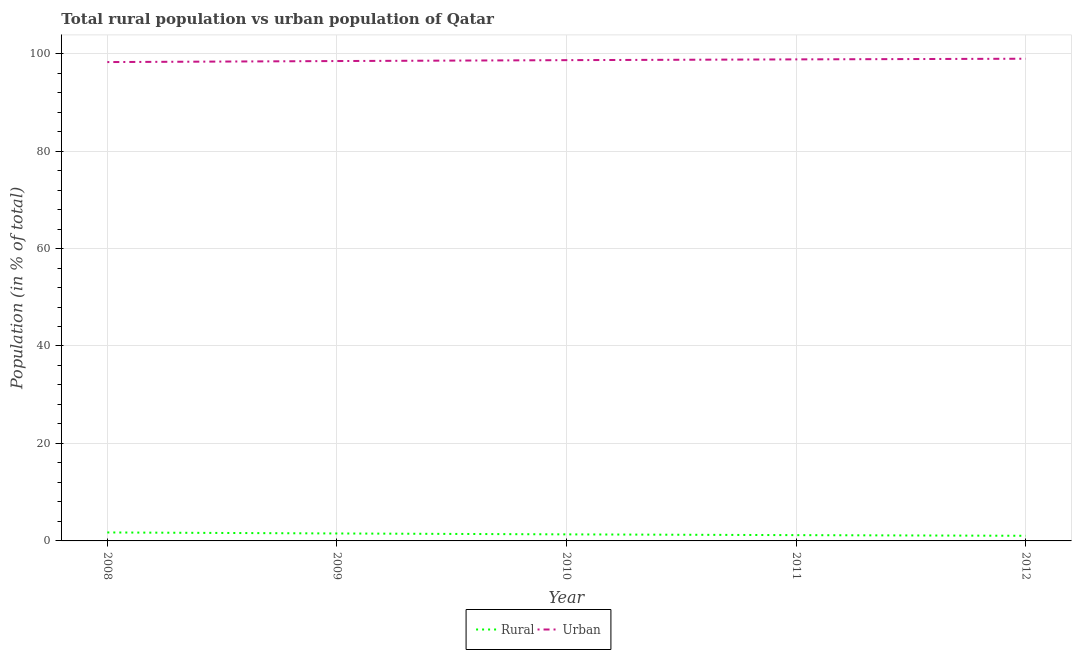Does the line corresponding to rural population intersect with the line corresponding to urban population?
Offer a terse response. No. What is the urban population in 2008?
Provide a short and direct response. 98.26. Across all years, what is the maximum urban population?
Offer a terse response. 98.95. Across all years, what is the minimum urban population?
Offer a very short reply. 98.26. In which year was the urban population maximum?
Your answer should be compact. 2012. What is the total urban population in the graph?
Provide a succinct answer. 493.14. What is the difference between the rural population in 2011 and that in 2012?
Your answer should be very brief. 0.13. What is the difference between the urban population in 2010 and the rural population in 2011?
Offer a very short reply. 97.47. What is the average rural population per year?
Your response must be concise. 1.37. In the year 2009, what is the difference between the urban population and rural population?
Keep it short and to the point. 96.94. In how many years, is the rural population greater than 12 %?
Ensure brevity in your answer.  0. What is the ratio of the rural population in 2008 to that in 2010?
Your answer should be compact. 1.29. What is the difference between the highest and the second highest rural population?
Offer a very short reply. 0.21. What is the difference between the highest and the lowest urban population?
Your answer should be compact. 0.69. In how many years, is the urban population greater than the average urban population taken over all years?
Your answer should be very brief. 3. Does the urban population monotonically increase over the years?
Give a very brief answer. Yes. How many lines are there?
Your answer should be very brief. 2. How many years are there in the graph?
Keep it short and to the point. 5. What is the difference between two consecutive major ticks on the Y-axis?
Your answer should be very brief. 20. Are the values on the major ticks of Y-axis written in scientific E-notation?
Give a very brief answer. No. Does the graph contain any zero values?
Offer a terse response. No. How many legend labels are there?
Make the answer very short. 2. What is the title of the graph?
Give a very brief answer. Total rural population vs urban population of Qatar. Does "Electricity and heat production" appear as one of the legend labels in the graph?
Your answer should be compact. No. What is the label or title of the Y-axis?
Your response must be concise. Population (in % of total). What is the Population (in % of total) of Rural in 2008?
Keep it short and to the point. 1.74. What is the Population (in % of total) of Urban in 2008?
Offer a very short reply. 98.26. What is the Population (in % of total) in Rural in 2009?
Your response must be concise. 1.53. What is the Population (in % of total) of Urban in 2009?
Provide a short and direct response. 98.47. What is the Population (in % of total) in Rural in 2010?
Offer a very short reply. 1.34. What is the Population (in % of total) in Urban in 2010?
Provide a succinct answer. 98.66. What is the Population (in % of total) of Rural in 2011?
Provide a succinct answer. 1.19. What is the Population (in % of total) of Urban in 2011?
Provide a succinct answer. 98.81. What is the Population (in % of total) of Rural in 2012?
Give a very brief answer. 1.05. What is the Population (in % of total) of Urban in 2012?
Your answer should be compact. 98.95. Across all years, what is the maximum Population (in % of total) in Rural?
Your answer should be very brief. 1.74. Across all years, what is the maximum Population (in % of total) of Urban?
Offer a very short reply. 98.95. Across all years, what is the minimum Population (in % of total) in Rural?
Keep it short and to the point. 1.05. Across all years, what is the minimum Population (in % of total) of Urban?
Offer a very short reply. 98.26. What is the total Population (in % of total) of Rural in the graph?
Keep it short and to the point. 6.86. What is the total Population (in % of total) in Urban in the graph?
Provide a succinct answer. 493.14. What is the difference between the Population (in % of total) in Rural in 2008 and that in 2009?
Provide a short and direct response. 0.21. What is the difference between the Population (in % of total) of Urban in 2008 and that in 2009?
Offer a terse response. -0.21. What is the difference between the Population (in % of total) in Rural in 2008 and that in 2010?
Give a very brief answer. 0.39. What is the difference between the Population (in % of total) of Urban in 2008 and that in 2010?
Provide a succinct answer. -0.39. What is the difference between the Population (in % of total) in Rural in 2008 and that in 2011?
Offer a terse response. 0.55. What is the difference between the Population (in % of total) in Urban in 2008 and that in 2011?
Give a very brief answer. -0.55. What is the difference between the Population (in % of total) in Rural in 2008 and that in 2012?
Provide a succinct answer. 0.69. What is the difference between the Population (in % of total) of Urban in 2008 and that in 2012?
Make the answer very short. -0.69. What is the difference between the Population (in % of total) in Rural in 2009 and that in 2010?
Offer a very short reply. 0.18. What is the difference between the Population (in % of total) of Urban in 2009 and that in 2010?
Make the answer very short. -0.18. What is the difference between the Population (in % of total) of Rural in 2009 and that in 2011?
Make the answer very short. 0.34. What is the difference between the Population (in % of total) in Urban in 2009 and that in 2011?
Give a very brief answer. -0.34. What is the difference between the Population (in % of total) of Rural in 2009 and that in 2012?
Your answer should be very brief. 0.48. What is the difference between the Population (in % of total) in Urban in 2009 and that in 2012?
Keep it short and to the point. -0.48. What is the difference between the Population (in % of total) in Rural in 2010 and that in 2011?
Provide a short and direct response. 0.16. What is the difference between the Population (in % of total) of Urban in 2010 and that in 2011?
Your response must be concise. -0.16. What is the difference between the Population (in % of total) in Rural in 2010 and that in 2012?
Provide a succinct answer. 0.29. What is the difference between the Population (in % of total) in Urban in 2010 and that in 2012?
Offer a very short reply. -0.29. What is the difference between the Population (in % of total) in Rural in 2011 and that in 2012?
Your answer should be very brief. 0.13. What is the difference between the Population (in % of total) in Urban in 2011 and that in 2012?
Ensure brevity in your answer.  -0.13. What is the difference between the Population (in % of total) in Rural in 2008 and the Population (in % of total) in Urban in 2009?
Keep it short and to the point. -96.73. What is the difference between the Population (in % of total) of Rural in 2008 and the Population (in % of total) of Urban in 2010?
Ensure brevity in your answer.  -96.92. What is the difference between the Population (in % of total) in Rural in 2008 and the Population (in % of total) in Urban in 2011?
Provide a short and direct response. -97.07. What is the difference between the Population (in % of total) in Rural in 2008 and the Population (in % of total) in Urban in 2012?
Make the answer very short. -97.21. What is the difference between the Population (in % of total) in Rural in 2009 and the Population (in % of total) in Urban in 2010?
Your answer should be very brief. -97.12. What is the difference between the Population (in % of total) in Rural in 2009 and the Population (in % of total) in Urban in 2011?
Provide a short and direct response. -97.28. What is the difference between the Population (in % of total) in Rural in 2009 and the Population (in % of total) in Urban in 2012?
Your answer should be compact. -97.42. What is the difference between the Population (in % of total) of Rural in 2010 and the Population (in % of total) of Urban in 2011?
Your answer should be very brief. -97.47. What is the difference between the Population (in % of total) of Rural in 2010 and the Population (in % of total) of Urban in 2012?
Your answer should be compact. -97.6. What is the difference between the Population (in % of total) in Rural in 2011 and the Population (in % of total) in Urban in 2012?
Offer a terse response. -97.76. What is the average Population (in % of total) of Rural per year?
Provide a short and direct response. 1.37. What is the average Population (in % of total) of Urban per year?
Your response must be concise. 98.63. In the year 2008, what is the difference between the Population (in % of total) in Rural and Population (in % of total) in Urban?
Your answer should be compact. -96.52. In the year 2009, what is the difference between the Population (in % of total) in Rural and Population (in % of total) in Urban?
Keep it short and to the point. -96.94. In the year 2010, what is the difference between the Population (in % of total) in Rural and Population (in % of total) in Urban?
Offer a very short reply. -97.31. In the year 2011, what is the difference between the Population (in % of total) in Rural and Population (in % of total) in Urban?
Keep it short and to the point. -97.62. In the year 2012, what is the difference between the Population (in % of total) in Rural and Population (in % of total) in Urban?
Keep it short and to the point. -97.89. What is the ratio of the Population (in % of total) in Rural in 2008 to that in 2009?
Provide a succinct answer. 1.14. What is the ratio of the Population (in % of total) in Urban in 2008 to that in 2009?
Your answer should be compact. 1. What is the ratio of the Population (in % of total) of Rural in 2008 to that in 2010?
Your response must be concise. 1.29. What is the ratio of the Population (in % of total) in Urban in 2008 to that in 2010?
Make the answer very short. 1. What is the ratio of the Population (in % of total) of Rural in 2008 to that in 2011?
Make the answer very short. 1.46. What is the ratio of the Population (in % of total) in Rural in 2008 to that in 2012?
Keep it short and to the point. 1.65. What is the ratio of the Population (in % of total) in Urban in 2008 to that in 2012?
Provide a succinct answer. 0.99. What is the ratio of the Population (in % of total) of Rural in 2009 to that in 2010?
Your response must be concise. 1.14. What is the ratio of the Population (in % of total) in Rural in 2009 to that in 2011?
Provide a short and direct response. 1.29. What is the ratio of the Population (in % of total) in Urban in 2009 to that in 2011?
Offer a terse response. 1. What is the ratio of the Population (in % of total) in Rural in 2009 to that in 2012?
Ensure brevity in your answer.  1.45. What is the ratio of the Population (in % of total) of Rural in 2010 to that in 2011?
Keep it short and to the point. 1.13. What is the ratio of the Population (in % of total) in Urban in 2010 to that in 2011?
Your response must be concise. 1. What is the ratio of the Population (in % of total) in Rural in 2010 to that in 2012?
Offer a very short reply. 1.28. What is the ratio of the Population (in % of total) in Urban in 2010 to that in 2012?
Provide a short and direct response. 1. What is the ratio of the Population (in % of total) in Rural in 2011 to that in 2012?
Your answer should be compact. 1.13. What is the ratio of the Population (in % of total) of Urban in 2011 to that in 2012?
Provide a short and direct response. 1. What is the difference between the highest and the second highest Population (in % of total) in Rural?
Keep it short and to the point. 0.21. What is the difference between the highest and the second highest Population (in % of total) in Urban?
Provide a succinct answer. 0.13. What is the difference between the highest and the lowest Population (in % of total) of Rural?
Provide a succinct answer. 0.69. What is the difference between the highest and the lowest Population (in % of total) in Urban?
Ensure brevity in your answer.  0.69. 